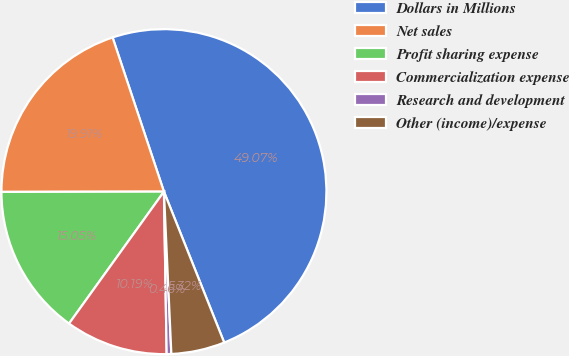Convert chart to OTSL. <chart><loc_0><loc_0><loc_500><loc_500><pie_chart><fcel>Dollars in Millions<fcel>Net sales<fcel>Profit sharing expense<fcel>Commercialization expense<fcel>Research and development<fcel>Other (income)/expense<nl><fcel>49.07%<fcel>19.91%<fcel>15.05%<fcel>10.19%<fcel>0.46%<fcel>5.32%<nl></chart> 